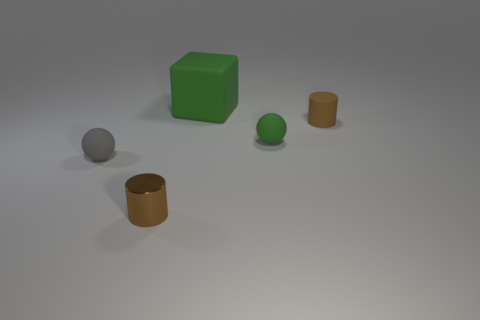Add 3 large brown blocks. How many objects exist? 8 Subtract all cylinders. How many objects are left? 3 Add 3 tiny rubber things. How many tiny rubber things are left? 6 Add 3 green spheres. How many green spheres exist? 4 Subtract 0 cyan cylinders. How many objects are left? 5 Subtract all small purple balls. Subtract all green cubes. How many objects are left? 4 